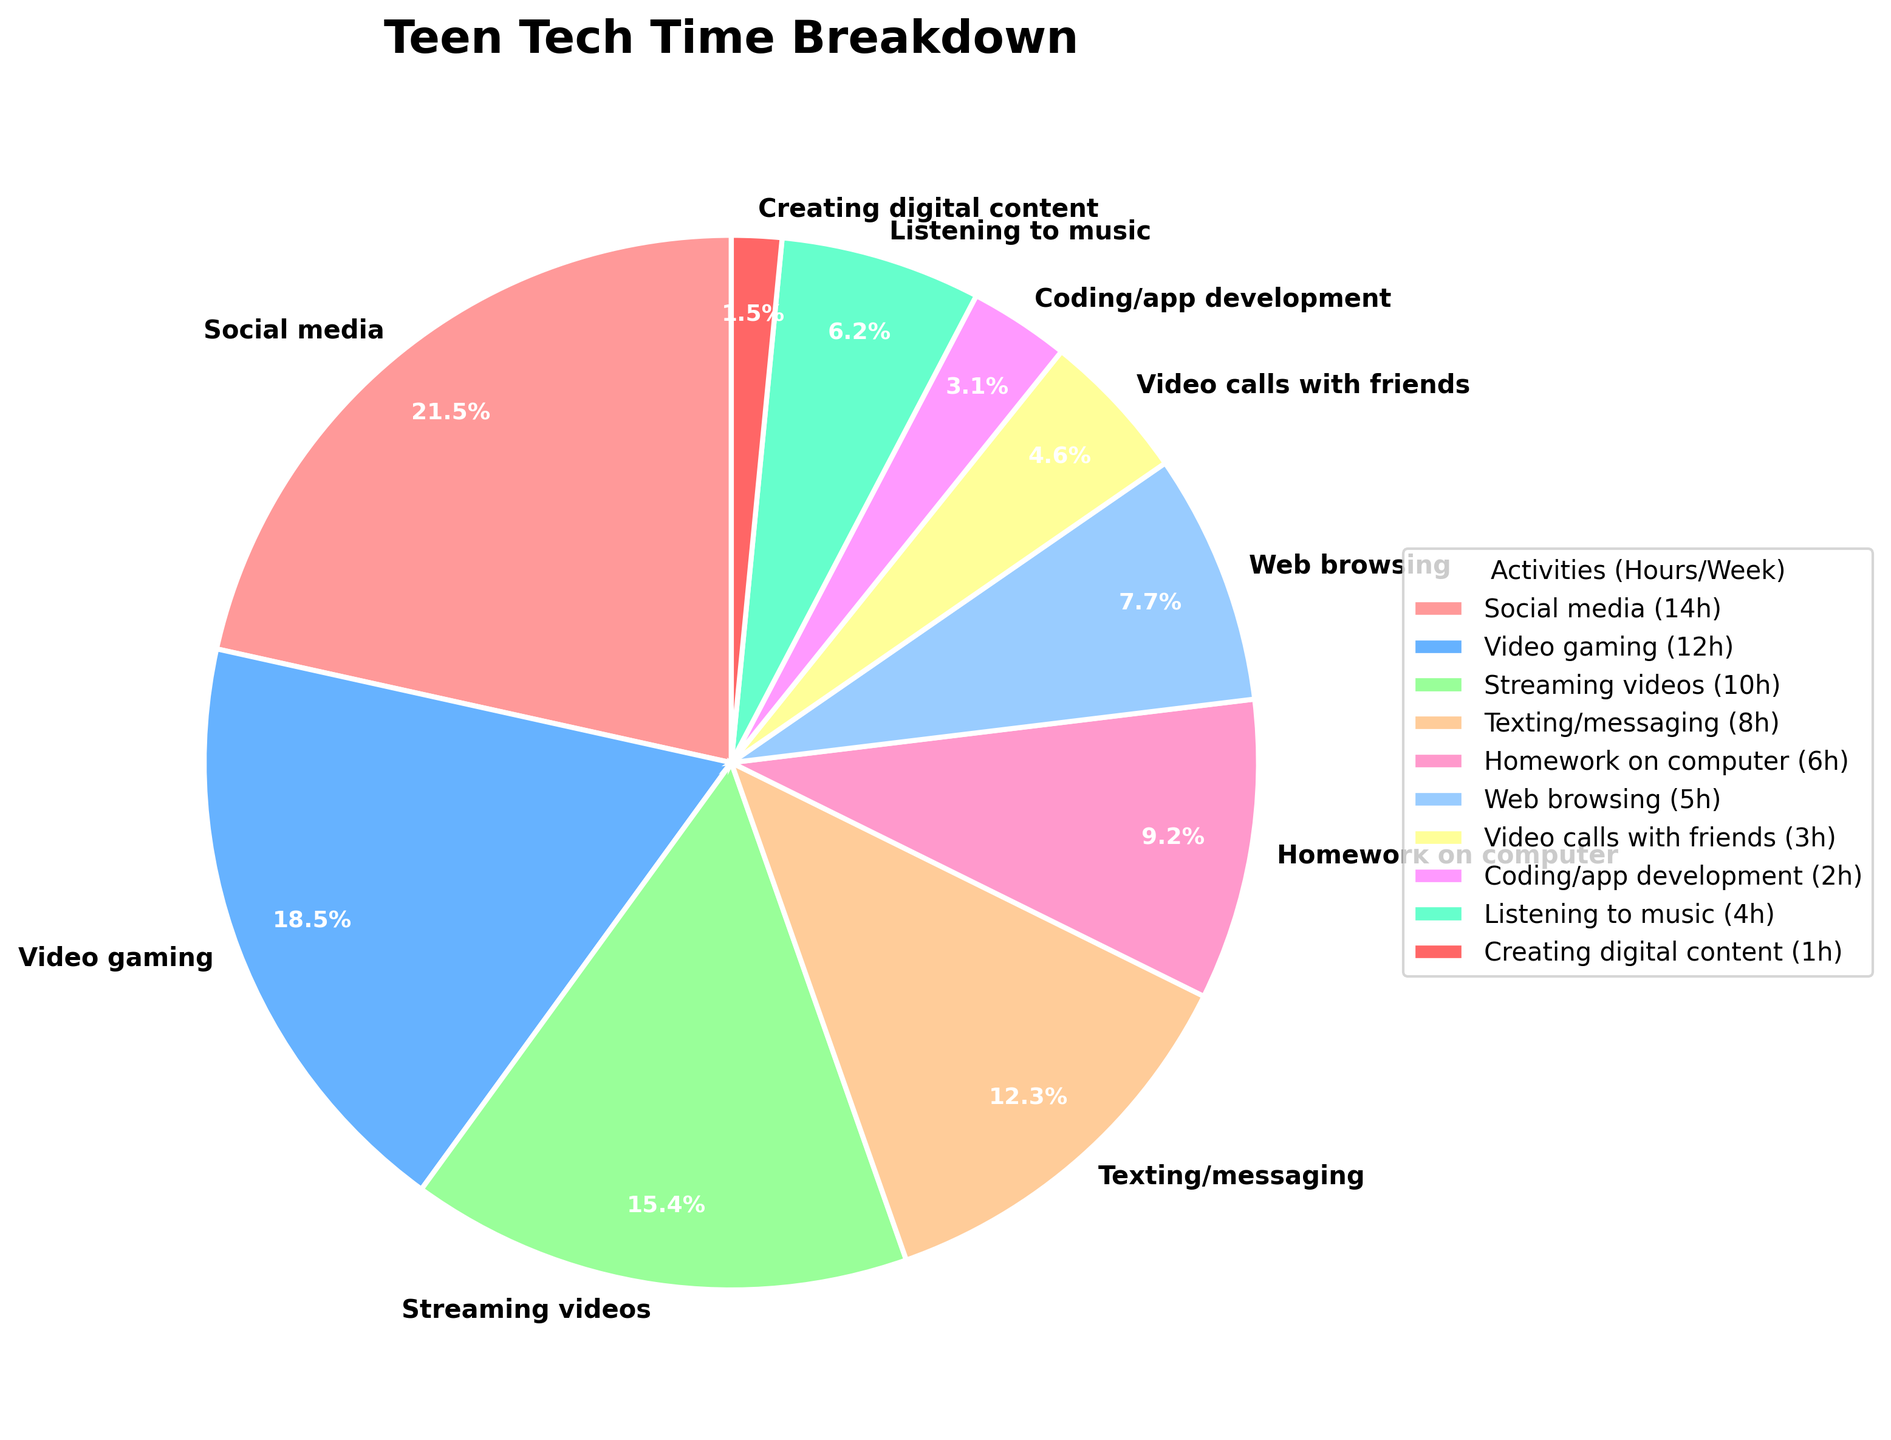What percentage of time do teens spend on social media? By looking at the pie chart, we can see the slice labeled "Social media" along with its percentage. This slice is marked at 14 hours per week, and the chart shows that it represents 29.2% of the total time.
Answer: 29.2% Which activity do teens spend the least amount of time on? The pie chart shows several activities, with the smallest slice representing the activity with the least hours per week. "Creating digital content" has the smallest slice, indicating 1 hour per week.
Answer: Creating digital content How much more time do teens spend on social media compared to coding/app development? The pie chart provides the hours spent on both activities: 14 hours for social media and 2 hours for coding/app development. The difference is calculated as 14 - 2.
Answer: 12 hours Which two activities have the combined total closest to the time spent on social media? By inspecting the pie chart, we calculate pairwise sums and find the pair with the sum closest to 14 hours. "Texting/messaging" (8h) and "Web browsing" (5h) combine to 13 hours, which is closest to 14 hours.
Answer: Texting/messaging and Web browsing What is the combined percentage of time spent on video gaming and creating digital content? The chart shows video gaming at 12 hours (25%) and creating digital content at 1 hour (2.1%). The combined percentage is 25% + 2.1%.
Answer: 27.1% Do teens spend more time on streaming videos or video calls with friends? By examining the slices representing each activity, we see that streaming videos appear larger and represent 10 hours per week, while video calls with friends are 3 hours per week.
Answer: Streaming videos How many more hours per week are spent on texting/messaging than on listening to music? The pie chart shows that texting/messaging is 8 hours per week, and listening to music is 4 hours per week. The difference is calculated as 8 - 4.
Answer: 4 hours Identify the activity represented by the pink-colored slice and its percentage. By matching the color pink in the figure legend with the pie chart slice, "Social media" is the activity denoted in pink, accounting for 29.2%.
Answer: Social media, 29.2% What is the average number of hours spent on the three most time-consuming activities? The pie chart shows the top three activities as social media (14h), video gaming (12h), and streaming videos (10h). The average is calculated as (14 + 12 + 10) / 3.
Answer: 12 hours Which activity requires less time: homework on the computer or web browsing, and by how much? The pie chart indicates homework on the computer at 6 hours and web browsing at 5 hours. The difference is calculated as 6 - 5.
Answer: Web browsing, 1 hour 